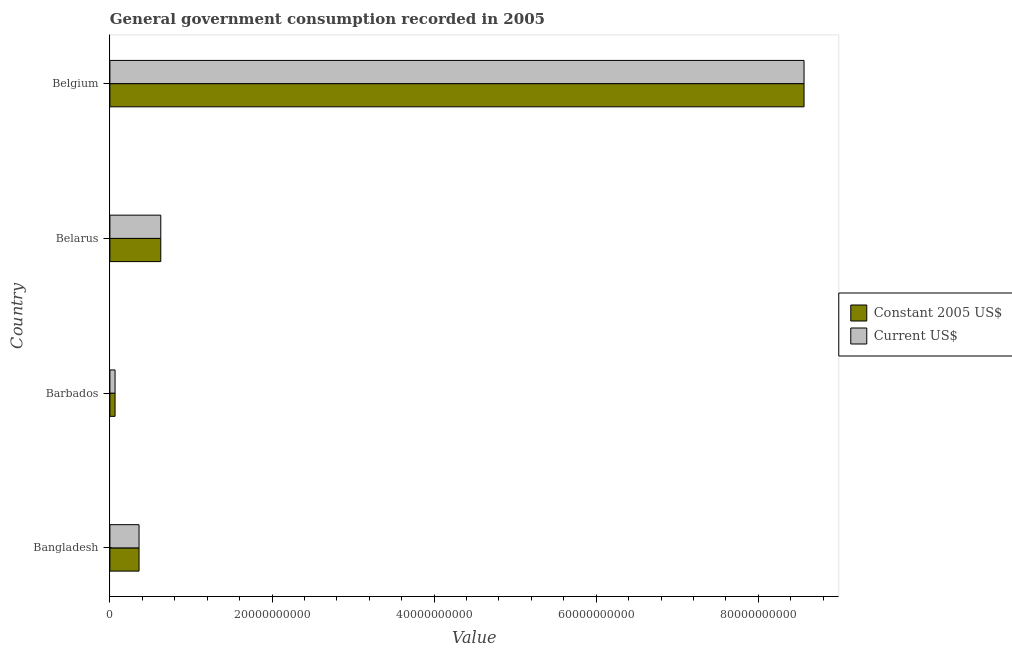How many groups of bars are there?
Your answer should be very brief. 4. Are the number of bars on each tick of the Y-axis equal?
Keep it short and to the point. Yes. How many bars are there on the 2nd tick from the bottom?
Make the answer very short. 2. What is the label of the 4th group of bars from the top?
Provide a short and direct response. Bangladesh. What is the value consumed in current us$ in Barbados?
Keep it short and to the point. 6.38e+08. Across all countries, what is the maximum value consumed in current us$?
Offer a terse response. 8.56e+1. Across all countries, what is the minimum value consumed in current us$?
Make the answer very short. 6.38e+08. In which country was the value consumed in current us$ maximum?
Offer a terse response. Belgium. In which country was the value consumed in constant 2005 us$ minimum?
Your answer should be compact. Barbados. What is the total value consumed in constant 2005 us$ in the graph?
Give a very brief answer. 9.62e+1. What is the difference between the value consumed in current us$ in Belarus and that in Belgium?
Provide a succinct answer. -7.94e+1. What is the difference between the value consumed in current us$ in Barbados and the value consumed in constant 2005 us$ in Belarus?
Your response must be concise. -5.64e+09. What is the average value consumed in current us$ per country?
Keep it short and to the point. 2.40e+1. In how many countries, is the value consumed in constant 2005 us$ greater than 48000000000 ?
Your response must be concise. 1. What is the ratio of the value consumed in current us$ in Bangladesh to that in Belgium?
Provide a succinct answer. 0.04. Is the value consumed in current us$ in Bangladesh less than that in Belgium?
Offer a very short reply. Yes. Is the difference between the value consumed in current us$ in Bangladesh and Belarus greater than the difference between the value consumed in constant 2005 us$ in Bangladesh and Belarus?
Offer a terse response. No. What is the difference between the highest and the second highest value consumed in current us$?
Offer a very short reply. 7.94e+1. What is the difference between the highest and the lowest value consumed in constant 2005 us$?
Provide a short and direct response. 8.50e+1. Is the sum of the value consumed in constant 2005 us$ in Barbados and Belgium greater than the maximum value consumed in current us$ across all countries?
Your answer should be compact. Yes. What does the 1st bar from the top in Belgium represents?
Your answer should be very brief. Current US$. What does the 1st bar from the bottom in Barbados represents?
Offer a terse response. Constant 2005 US$. How many bars are there?
Offer a terse response. 8. Are all the bars in the graph horizontal?
Make the answer very short. Yes. Does the graph contain any zero values?
Your answer should be very brief. No. Does the graph contain grids?
Give a very brief answer. No. Where does the legend appear in the graph?
Make the answer very short. Center right. What is the title of the graph?
Make the answer very short. General government consumption recorded in 2005. What is the label or title of the X-axis?
Offer a terse response. Value. What is the Value in Constant 2005 US$ in Bangladesh?
Provide a succinct answer. 3.60e+09. What is the Value of Current US$ in Bangladesh?
Provide a short and direct response. 3.60e+09. What is the Value of Constant 2005 US$ in Barbados?
Provide a succinct answer. 6.38e+08. What is the Value in Current US$ in Barbados?
Provide a short and direct response. 6.38e+08. What is the Value of Constant 2005 US$ in Belarus?
Keep it short and to the point. 6.28e+09. What is the Value of Current US$ in Belarus?
Provide a short and direct response. 6.28e+09. What is the Value of Constant 2005 US$ in Belgium?
Your answer should be compact. 8.56e+1. What is the Value of Current US$ in Belgium?
Provide a succinct answer. 8.56e+1. Across all countries, what is the maximum Value of Constant 2005 US$?
Your response must be concise. 8.56e+1. Across all countries, what is the maximum Value in Current US$?
Give a very brief answer. 8.56e+1. Across all countries, what is the minimum Value in Constant 2005 US$?
Make the answer very short. 6.38e+08. Across all countries, what is the minimum Value of Current US$?
Your response must be concise. 6.38e+08. What is the total Value of Constant 2005 US$ in the graph?
Make the answer very short. 9.62e+1. What is the total Value of Current US$ in the graph?
Offer a terse response. 9.62e+1. What is the difference between the Value of Constant 2005 US$ in Bangladesh and that in Barbados?
Offer a very short reply. 2.96e+09. What is the difference between the Value of Current US$ in Bangladesh and that in Barbados?
Give a very brief answer. 2.96e+09. What is the difference between the Value in Constant 2005 US$ in Bangladesh and that in Belarus?
Your response must be concise. -2.68e+09. What is the difference between the Value of Current US$ in Bangladesh and that in Belarus?
Ensure brevity in your answer.  -2.68e+09. What is the difference between the Value in Constant 2005 US$ in Bangladesh and that in Belgium?
Your answer should be compact. -8.20e+1. What is the difference between the Value of Current US$ in Bangladesh and that in Belgium?
Your answer should be very brief. -8.20e+1. What is the difference between the Value in Constant 2005 US$ in Barbados and that in Belarus?
Your answer should be compact. -5.64e+09. What is the difference between the Value of Current US$ in Barbados and that in Belarus?
Give a very brief answer. -5.64e+09. What is the difference between the Value of Constant 2005 US$ in Barbados and that in Belgium?
Offer a terse response. -8.50e+1. What is the difference between the Value in Current US$ in Barbados and that in Belgium?
Make the answer very short. -8.50e+1. What is the difference between the Value in Constant 2005 US$ in Belarus and that in Belgium?
Your answer should be compact. -7.94e+1. What is the difference between the Value of Current US$ in Belarus and that in Belgium?
Your response must be concise. -7.94e+1. What is the difference between the Value in Constant 2005 US$ in Bangladesh and the Value in Current US$ in Barbados?
Offer a very short reply. 2.96e+09. What is the difference between the Value of Constant 2005 US$ in Bangladesh and the Value of Current US$ in Belarus?
Your answer should be very brief. -2.68e+09. What is the difference between the Value in Constant 2005 US$ in Bangladesh and the Value in Current US$ in Belgium?
Your response must be concise. -8.20e+1. What is the difference between the Value of Constant 2005 US$ in Barbados and the Value of Current US$ in Belarus?
Provide a succinct answer. -5.64e+09. What is the difference between the Value in Constant 2005 US$ in Barbados and the Value in Current US$ in Belgium?
Ensure brevity in your answer.  -8.50e+1. What is the difference between the Value of Constant 2005 US$ in Belarus and the Value of Current US$ in Belgium?
Your answer should be compact. -7.94e+1. What is the average Value of Constant 2005 US$ per country?
Provide a short and direct response. 2.40e+1. What is the average Value in Current US$ per country?
Ensure brevity in your answer.  2.40e+1. What is the difference between the Value of Constant 2005 US$ and Value of Current US$ in Belgium?
Provide a short and direct response. 0. What is the ratio of the Value in Constant 2005 US$ in Bangladesh to that in Barbados?
Provide a short and direct response. 5.64. What is the ratio of the Value of Current US$ in Bangladesh to that in Barbados?
Ensure brevity in your answer.  5.64. What is the ratio of the Value in Constant 2005 US$ in Bangladesh to that in Belarus?
Your response must be concise. 0.57. What is the ratio of the Value in Current US$ in Bangladesh to that in Belarus?
Keep it short and to the point. 0.57. What is the ratio of the Value in Constant 2005 US$ in Bangladesh to that in Belgium?
Keep it short and to the point. 0.04. What is the ratio of the Value in Current US$ in Bangladesh to that in Belgium?
Give a very brief answer. 0.04. What is the ratio of the Value of Constant 2005 US$ in Barbados to that in Belarus?
Your answer should be very brief. 0.1. What is the ratio of the Value of Current US$ in Barbados to that in Belarus?
Provide a succinct answer. 0.1. What is the ratio of the Value in Constant 2005 US$ in Barbados to that in Belgium?
Provide a succinct answer. 0.01. What is the ratio of the Value of Current US$ in Barbados to that in Belgium?
Offer a very short reply. 0.01. What is the ratio of the Value of Constant 2005 US$ in Belarus to that in Belgium?
Your answer should be compact. 0.07. What is the ratio of the Value in Current US$ in Belarus to that in Belgium?
Ensure brevity in your answer.  0.07. What is the difference between the highest and the second highest Value of Constant 2005 US$?
Your answer should be very brief. 7.94e+1. What is the difference between the highest and the second highest Value in Current US$?
Offer a very short reply. 7.94e+1. What is the difference between the highest and the lowest Value of Constant 2005 US$?
Your answer should be compact. 8.50e+1. What is the difference between the highest and the lowest Value in Current US$?
Give a very brief answer. 8.50e+1. 